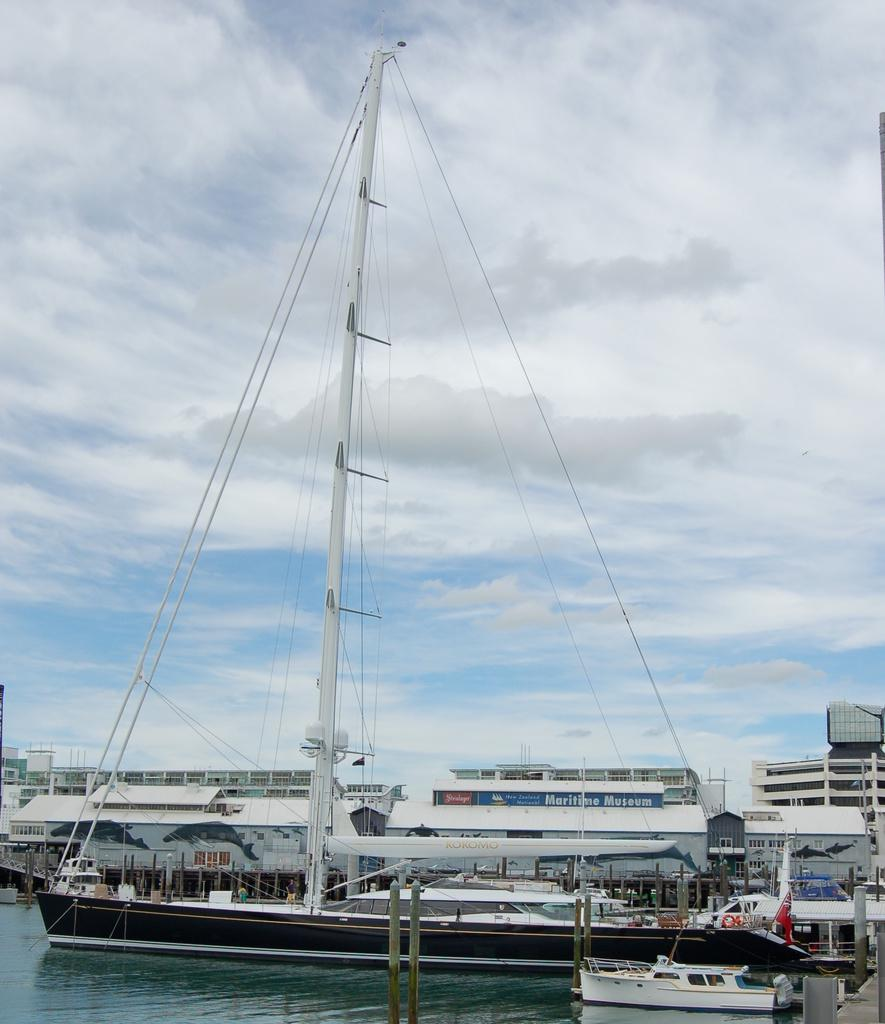What can be seen in the sky in the background of the image? There are clouds in the sky in the background of the image. What type of structures are present in the image? There are buildings in the image. What mode of transportation can be seen in the image? There is a ship and a boat in the image. What are the poles used for in the image? The purpose of the poles in the image is not specified, but they could be used for various purposes such as signage or lighting. What is the flag attached to in the image? The flag is attached to a pole in the image. What is the primary natural element visible in the image? Water is visible in the image. Can you describe any other objects present in the image? There are other objects in the image, but their specific details are not mentioned in the provided facts. How much income does the boat generate in the image? The image does not provide any information about the boat's income, as it is not a real-life scenario. 